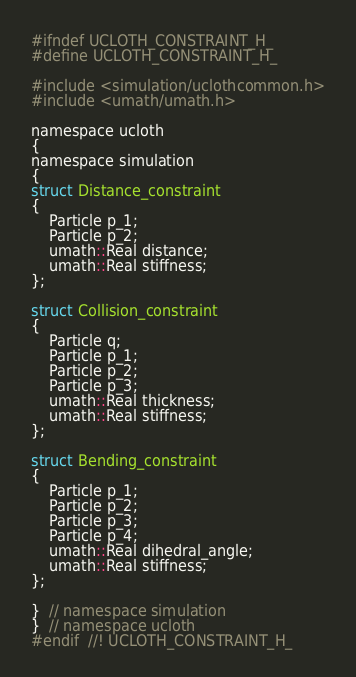Convert code to text. <code><loc_0><loc_0><loc_500><loc_500><_C_>#ifndef UCLOTH_CONSTRAINT_H_
#define UCLOTH_CONSTRAINT_H_

#include <simulation/uclothcommon.h>
#include <umath/umath.h>

namespace ucloth
{
namespace simulation
{
struct Distance_constraint
{
    Particle p_1;
    Particle p_2;
    umath::Real distance;
    umath::Real stiffness;
};

struct Collision_constraint
{
    Particle q;
    Particle p_1;
    Particle p_2;
    Particle p_3;
    umath::Real thickness;
    umath::Real stiffness;
};

struct Bending_constraint
{
    Particle p_1;
    Particle p_2;
    Particle p_3;
    Particle p_4;
    umath::Real dihedral_angle;
    umath::Real stiffness;
};

}  // namespace simulation
}  // namespace ucloth
#endif  //! UCLOTH_CONSTRAINT_H_</code> 